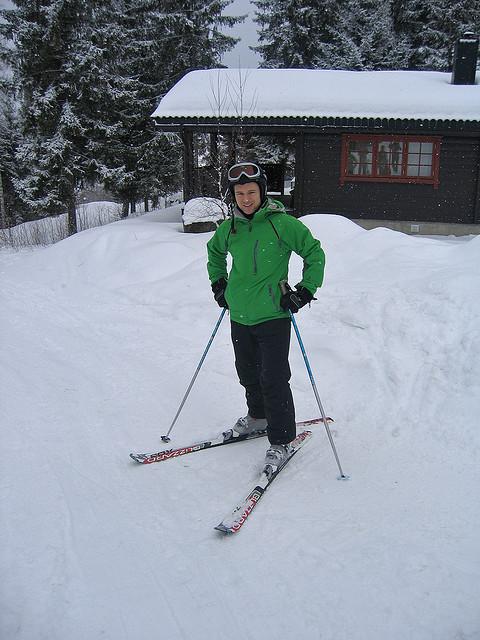Is the skier wearing goggles?
Quick response, please. Yes. Which foot is facing more towards the camera?
Concise answer only. Left. How many panes in the window?
Give a very brief answer. 18. 